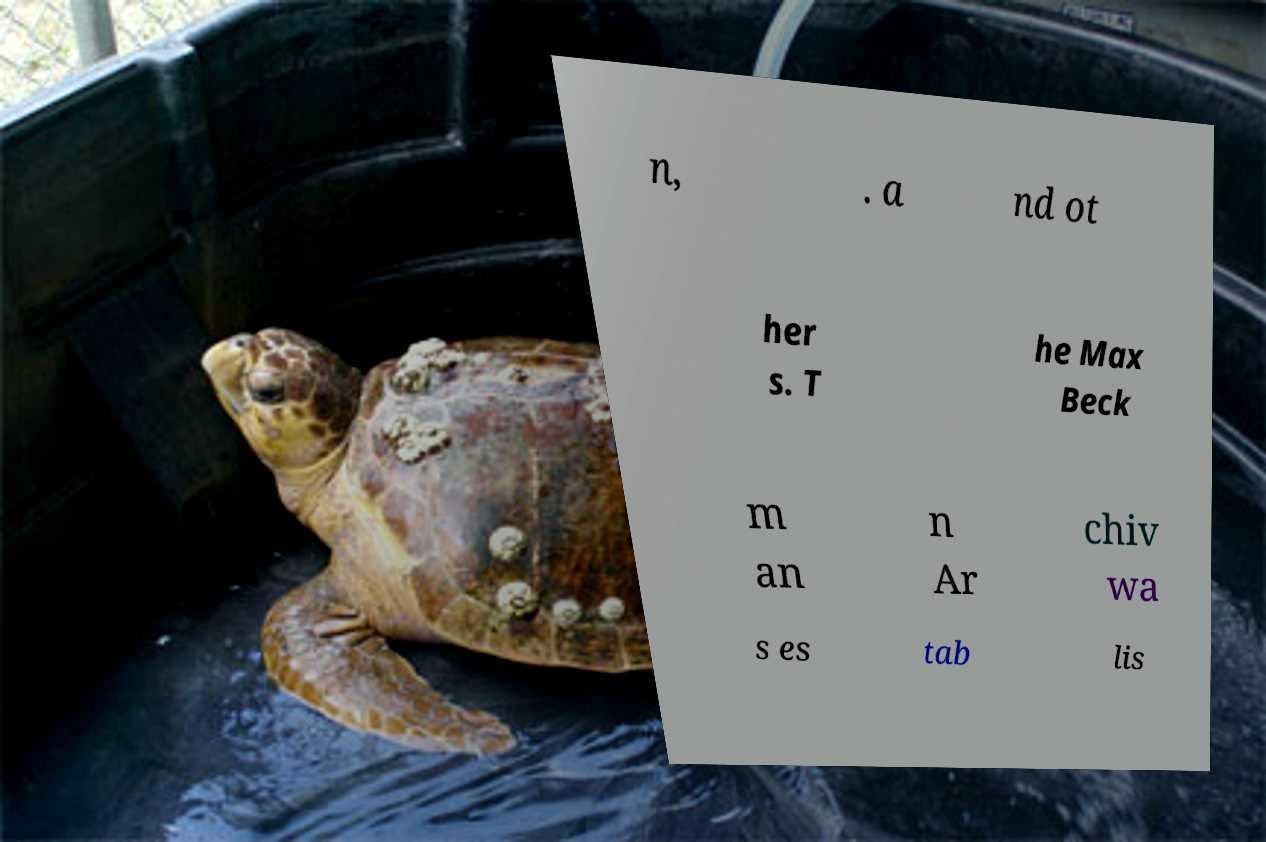Please identify and transcribe the text found in this image. n, . a nd ot her s. T he Max Beck m an n Ar chiv wa s es tab lis 